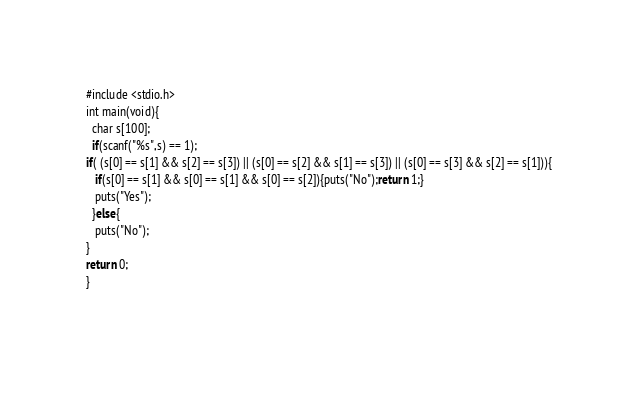<code> <loc_0><loc_0><loc_500><loc_500><_C_>#include <stdio.h>
int main(void){
  char s[100];
  if(scanf("%s",s) == 1);
if( (s[0] == s[1] && s[2] == s[3]) || (s[0] == s[2] && s[1] == s[3]) || (s[0] == s[3] && s[2] == s[1])){
   if(s[0] == s[1] && s[0] == s[1] && s[0] == s[2]){puts("No");return 1;}
   puts("Yes");
  }else{
   puts("No");
}
return 0;
}
  
</code> 